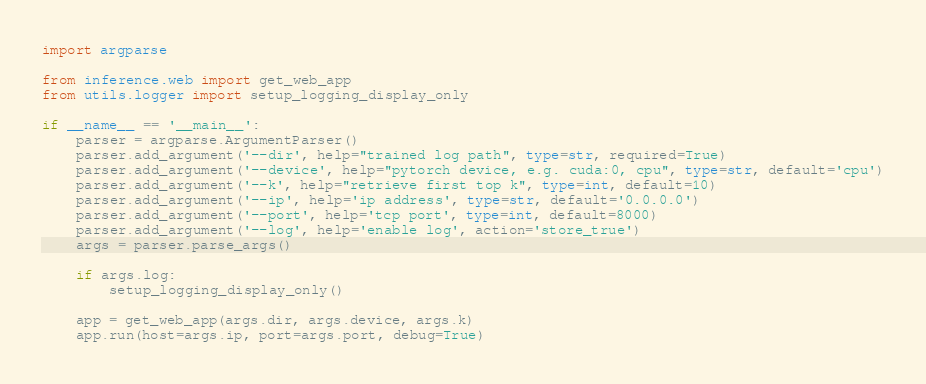<code> <loc_0><loc_0><loc_500><loc_500><_Python_>import argparse

from inference.web import get_web_app
from utils.logger import setup_logging_display_only

if __name__ == '__main__':
    parser = argparse.ArgumentParser()
    parser.add_argument('--dir', help="trained log path", type=str, required=True)
    parser.add_argument('--device', help="pytorch device, e.g. cuda:0, cpu", type=str, default='cpu')
    parser.add_argument('--k', help="retrieve first top k", type=int, default=10)
    parser.add_argument('--ip', help='ip address', type=str, default='0.0.0.0')
    parser.add_argument('--port', help='tcp port', type=int, default=8000)
    parser.add_argument('--log', help='enable log', action='store_true')
    args = parser.parse_args()

    if args.log:
        setup_logging_display_only()

    app = get_web_app(args.dir, args.device, args.k)
    app.run(host=args.ip, port=args.port, debug=True)
</code> 